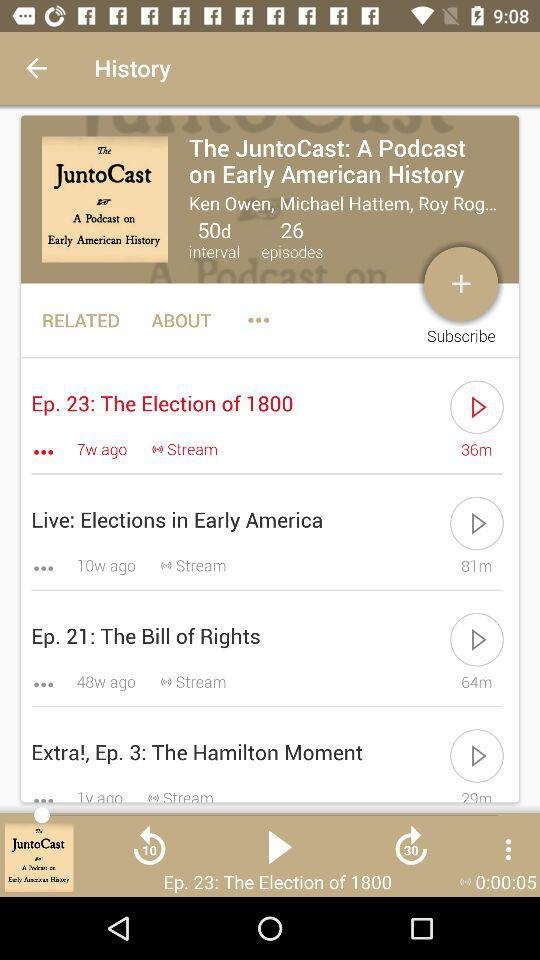Which episode has been selected? The selected episode is "The Election of 1800". 